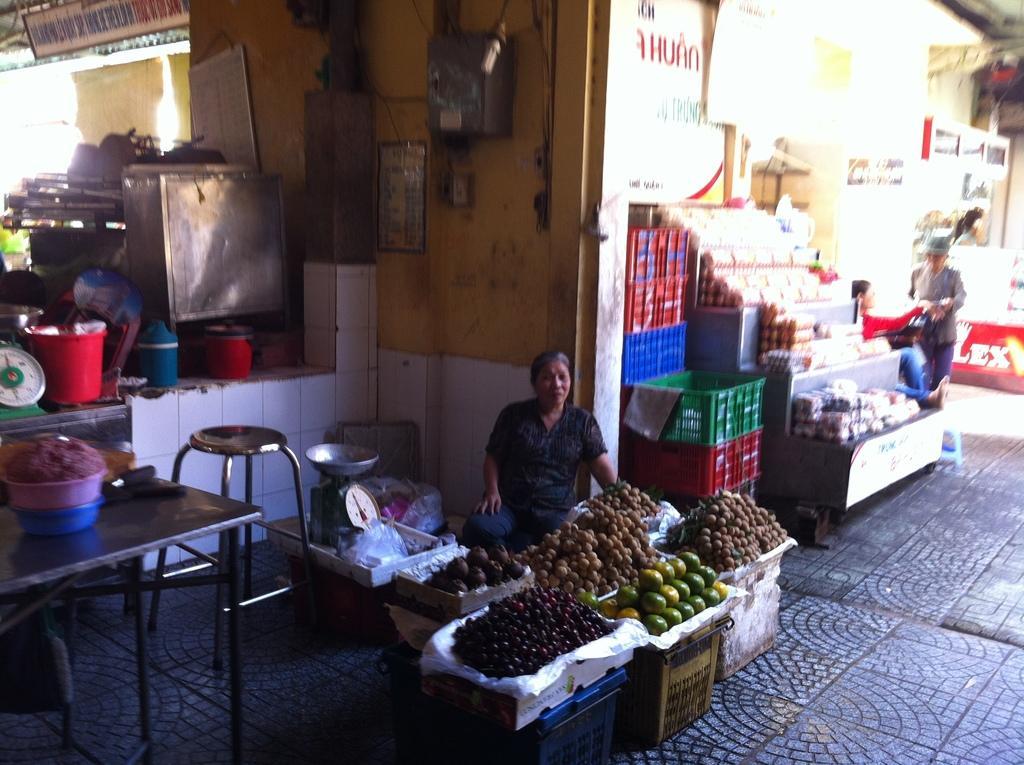How would you summarize this image in a sentence or two? In this picture we can see baskets, fruits, plastic covers, weighing machines, stool, boxes, name boards, posters, boards, table and some objects and some people. 